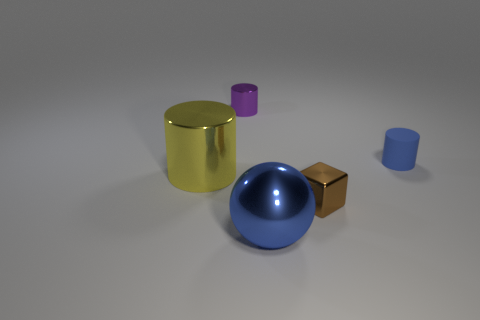Add 5 metal balls. How many objects exist? 10 Subtract all blocks. How many objects are left? 4 Add 4 yellow cylinders. How many yellow cylinders are left? 5 Add 1 yellow metal cylinders. How many yellow metal cylinders exist? 2 Subtract 1 purple cylinders. How many objects are left? 4 Subtract all large blue metal blocks. Subtract all blue matte objects. How many objects are left? 4 